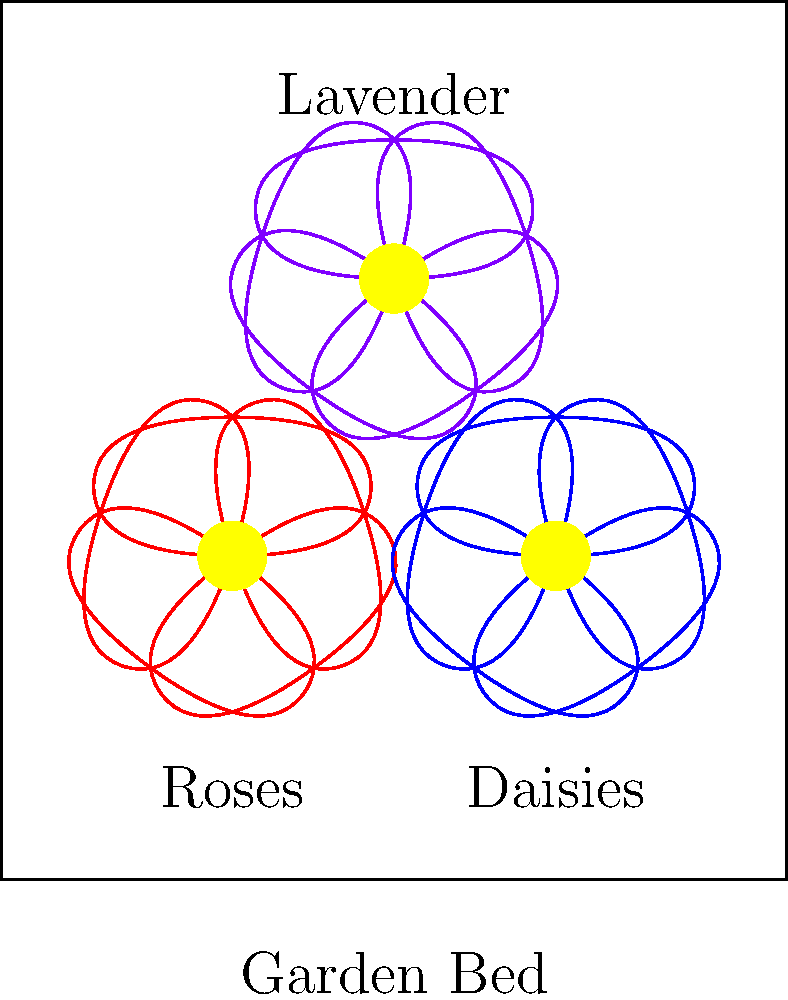In our care home garden, we want to arrange flowers in a way that creates a harmonious and visually appealing display. We have three types of flowers: roses, daisies, and lavender. If we want to ensure that no two adjacent flowers are of the same type, how many different ways can we arrange these three types of flowers in a circular garden bed? Let's approach this step-by-step:

1. We have 3 types of flowers to arrange in a circular pattern.

2. In a circular arrangement, we only need to consider the relative positions of the flowers, not the absolute starting point. This is because rotations of the same arrangement are considered identical.

3. We can start by placing any of the three flower types in the first position. Let's say we start with a rose.

4. For the second position, we have two choices: either a daisy or lavender.

5. For the third position, we must choose the flower type that hasn't been used yet.

6. This completes one arrangement. Now, let's count the possibilities:
   - Start with rose: 2 possibilities (rose-daisy-lavender or rose-lavender-daisy)
   - Start with daisy: 2 possibilities (daisy-rose-lavender or daisy-lavender-rose)
   - Start with lavender: 2 possibilities (lavender-rose-daisy or lavender-daisy-rose)

7. In total, we have $2 + 2 + 2 = 6$ possible arrangements.

8. However, remember that in a circular arrangement, rotations of the same arrangement are considered identical. Each unique arrangement can be rotated in 3 ways.

9. Therefore, we need to divide our total by 3: $6 \div 3 = 2$

Thus, there are 2 unique ways to arrange the three types of flowers in a circular garden bed with no adjacent flowers of the same type.
Answer: 2 ways 